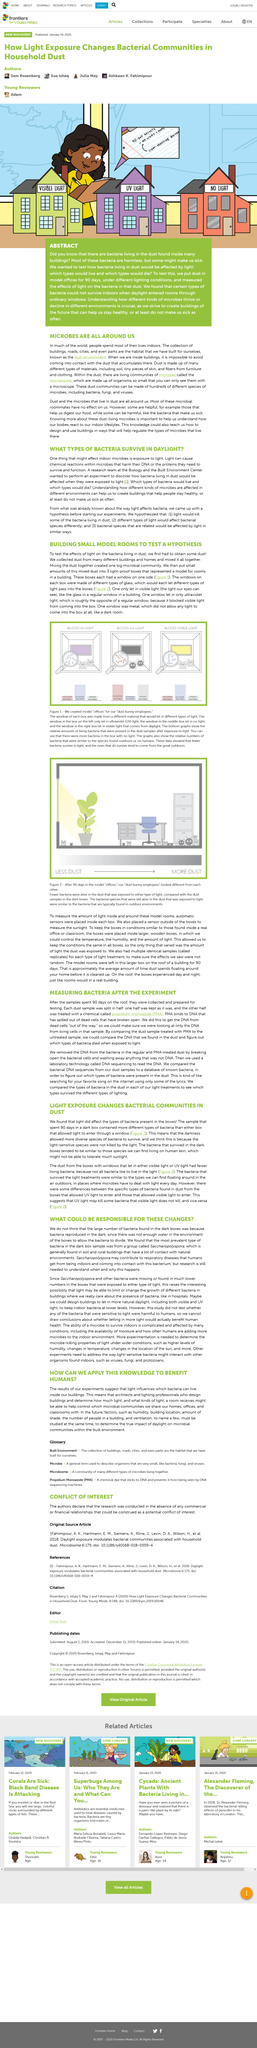Specify some key components in this picture. According to the article "WHAT COULD BE RESPONSIBLE FOR THESE CHANGES?", "Saccharopolyspora" bacteria is normally found in soil and rural buildings that have a lot of contact with natural environments. The data presented in the graphs indicates that bacteria are more likely to survive in environments with less light, and the ones that do survive typically originate from outdoor sources. The most prevalent type of bacteria found in the dark box was a group called Saccharopolyspora, which was present in significant numbers. The article mentions that exposure to both UV light and visible light can kill bacteria. The exposure to either type of light resulted in fewer bacteria being alive in the dust. 